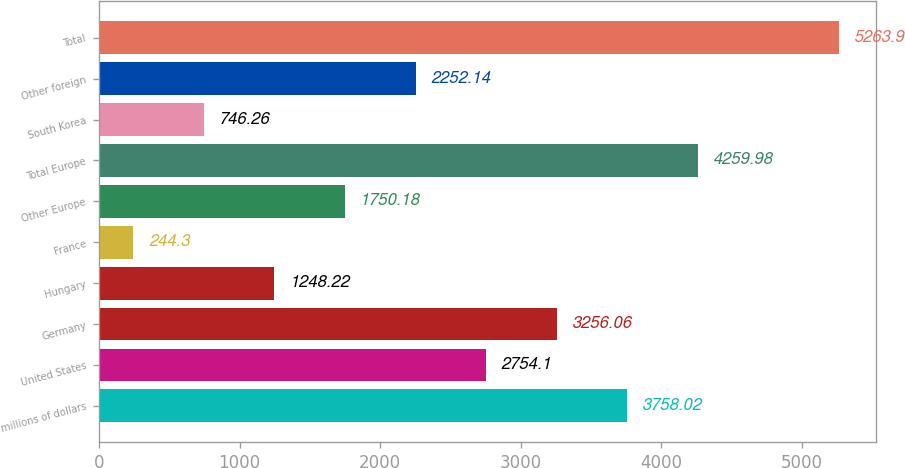Convert chart. <chart><loc_0><loc_0><loc_500><loc_500><bar_chart><fcel>millions of dollars<fcel>United States<fcel>Germany<fcel>Hungary<fcel>France<fcel>Other Europe<fcel>Total Europe<fcel>South Korea<fcel>Other foreign<fcel>Total<nl><fcel>3758.02<fcel>2754.1<fcel>3256.06<fcel>1248.22<fcel>244.3<fcel>1750.18<fcel>4259.98<fcel>746.26<fcel>2252.14<fcel>5263.9<nl></chart> 